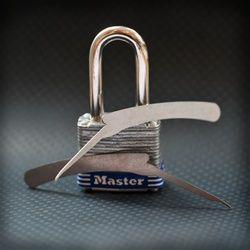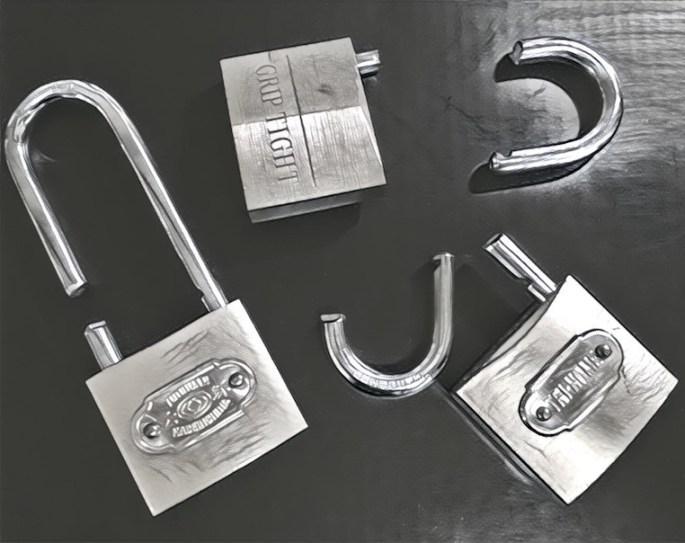The first image is the image on the left, the second image is the image on the right. Assess this claim about the two images: "An image of an antique-looking lock and key set includes a heart-shaped element.". Correct or not? Answer yes or no. No. The first image is the image on the left, the second image is the image on the right. Evaluate the accuracy of this statement regarding the images: "The lock in the image on the right is in the locked position.". Is it true? Answer yes or no. No. 